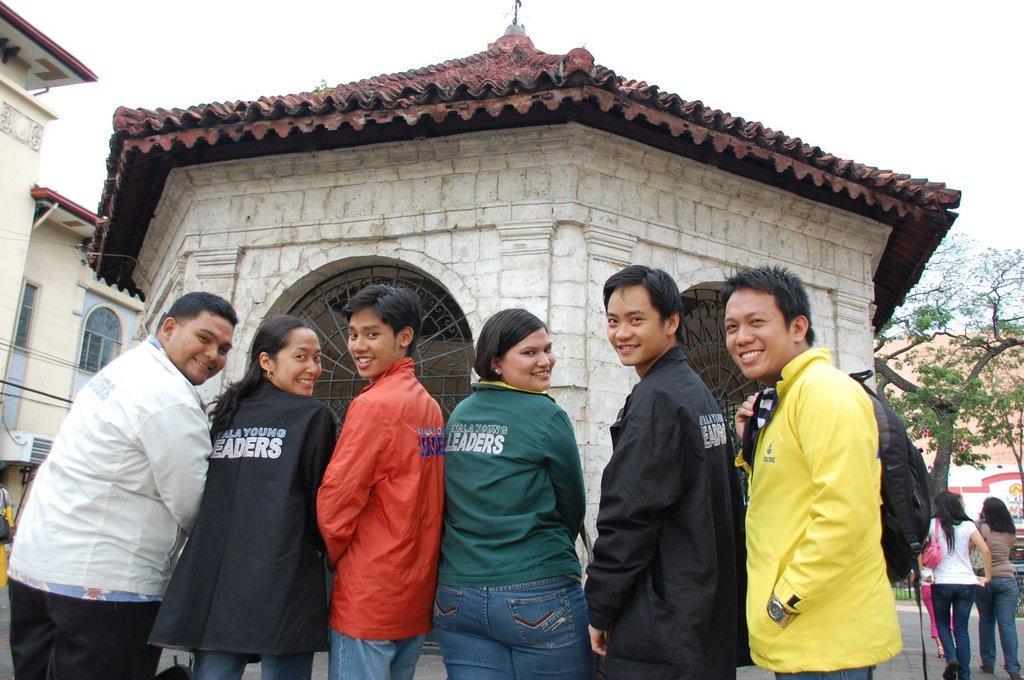Could you give a brief overview of what you see in this image? In this image I can see a group of people. On the right side, I can see a tree. In the background, I can see the buildings and the sky. 